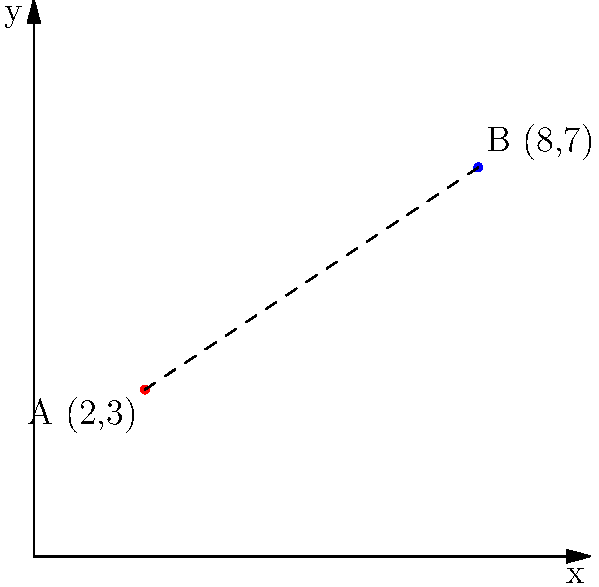Two research institutions, A and B, are plotted on a coordinate plane representing their geographic locations. Institution A is located at (2,3) and Institution B is at (8,7). As part of a new collaboration initiative, you need to calculate the straight-line distance between these two institutions. What is the distance between A and B to the nearest tenth of a unit? To find the distance between two points on a coordinate plane, we can use the distance formula:

$$ d = \sqrt{(x_2 - x_1)^2 + (y_2 - y_1)^2} $$

Where $(x_1, y_1)$ are the coordinates of the first point and $(x_2, y_2)$ are the coordinates of the second point.

Let's plug in our values:
* A: $(x_1, y_1) = (2, 3)$
* B: $(x_2, y_2) = (8, 7)$

$$ d = \sqrt{(8 - 2)^2 + (7 - 3)^2} $$

Now, let's solve step by step:

1) $d = \sqrt{6^2 + 4^2}$
2) $d = \sqrt{36 + 16}$
3) $d = \sqrt{52}$
4) $d \approx 7.2111$

Rounding to the nearest tenth, we get 7.2 units.
Answer: 7.2 units 